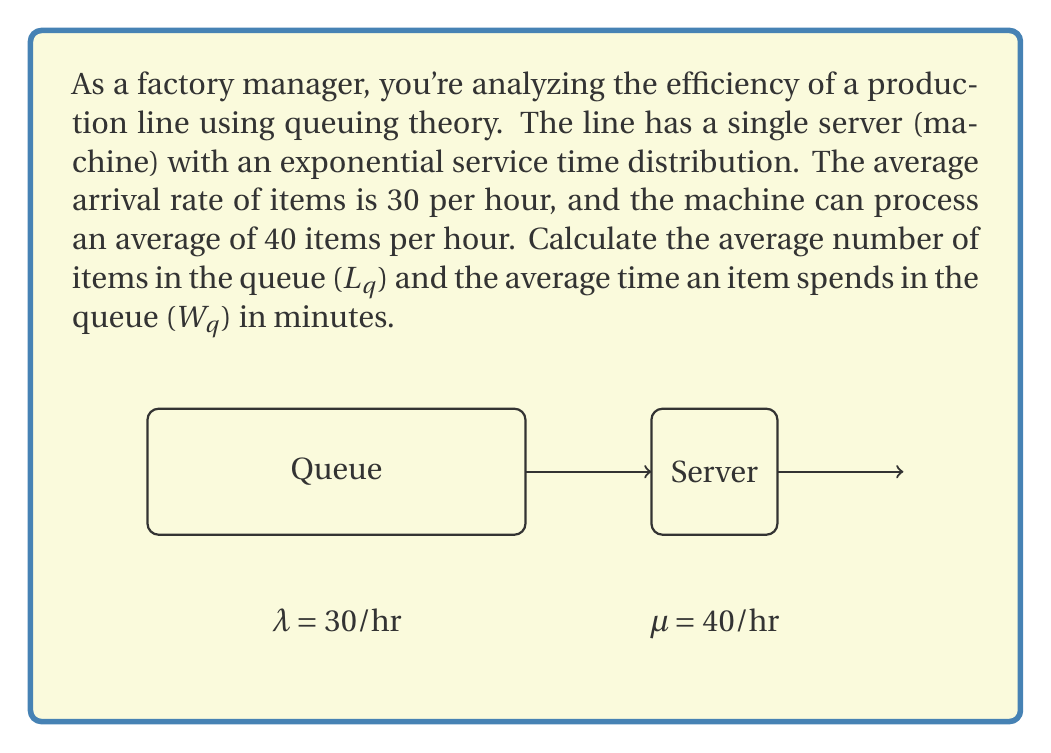Could you help me with this problem? Let's solve this step-by-step using the M/M/1 queuing model:

1) First, let's define our variables:
   $\lambda$ = arrival rate = 30 items/hour
   $\mu$ = service rate = 40 items/hour

2) Calculate the utilization factor $\rho$:
   $$\rho = \frac{\lambda}{\mu} = \frac{30}{40} = 0.75$$

3) For an M/M/1 queue, the average number of items in the queue (Lq) is given by:
   $$L_q = \frac{\rho^2}{1-\rho} = \frac{0.75^2}{1-0.75} = \frac{0.5625}{0.25} = 2.25$$

4) The average time an item spends in the queue (Wq) is related to Lq by Little's Law:
   $$W_q = \frac{L_q}{\lambda}$$

5) Substituting our values:
   $$W_q = \frac{2.25}{30} = 0.075 \text{ hours}$$

6) Convert Wq to minutes:
   $$W_q = 0.075 \text{ hours} \times 60 \text{ min/hour} = 4.5 \text{ minutes}$$

Thus, on average, there are 2.25 items in the queue, and each item spends 4.5 minutes waiting in the queue.
Answer: $L_q = 2.25$ items, $W_q = 4.5$ minutes 